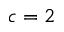<formula> <loc_0><loc_0><loc_500><loc_500>c = 2</formula> 